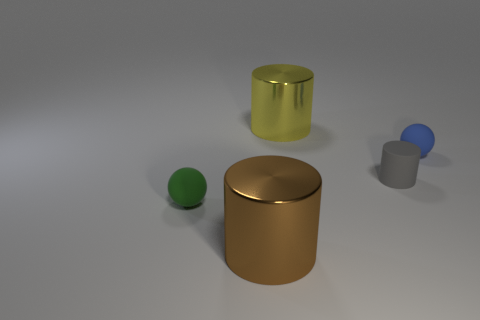Add 3 big green spheres. How many objects exist? 8 Subtract all spheres. How many objects are left? 3 Subtract all yellow metal blocks. Subtract all brown cylinders. How many objects are left? 4 Add 5 small rubber cylinders. How many small rubber cylinders are left? 6 Add 1 balls. How many balls exist? 3 Subtract 0 green cubes. How many objects are left? 5 